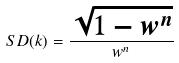Convert formula to latex. <formula><loc_0><loc_0><loc_500><loc_500>S D ( k ) = \frac { \sqrt { 1 - w ^ { n } } } { w ^ { n } }</formula> 